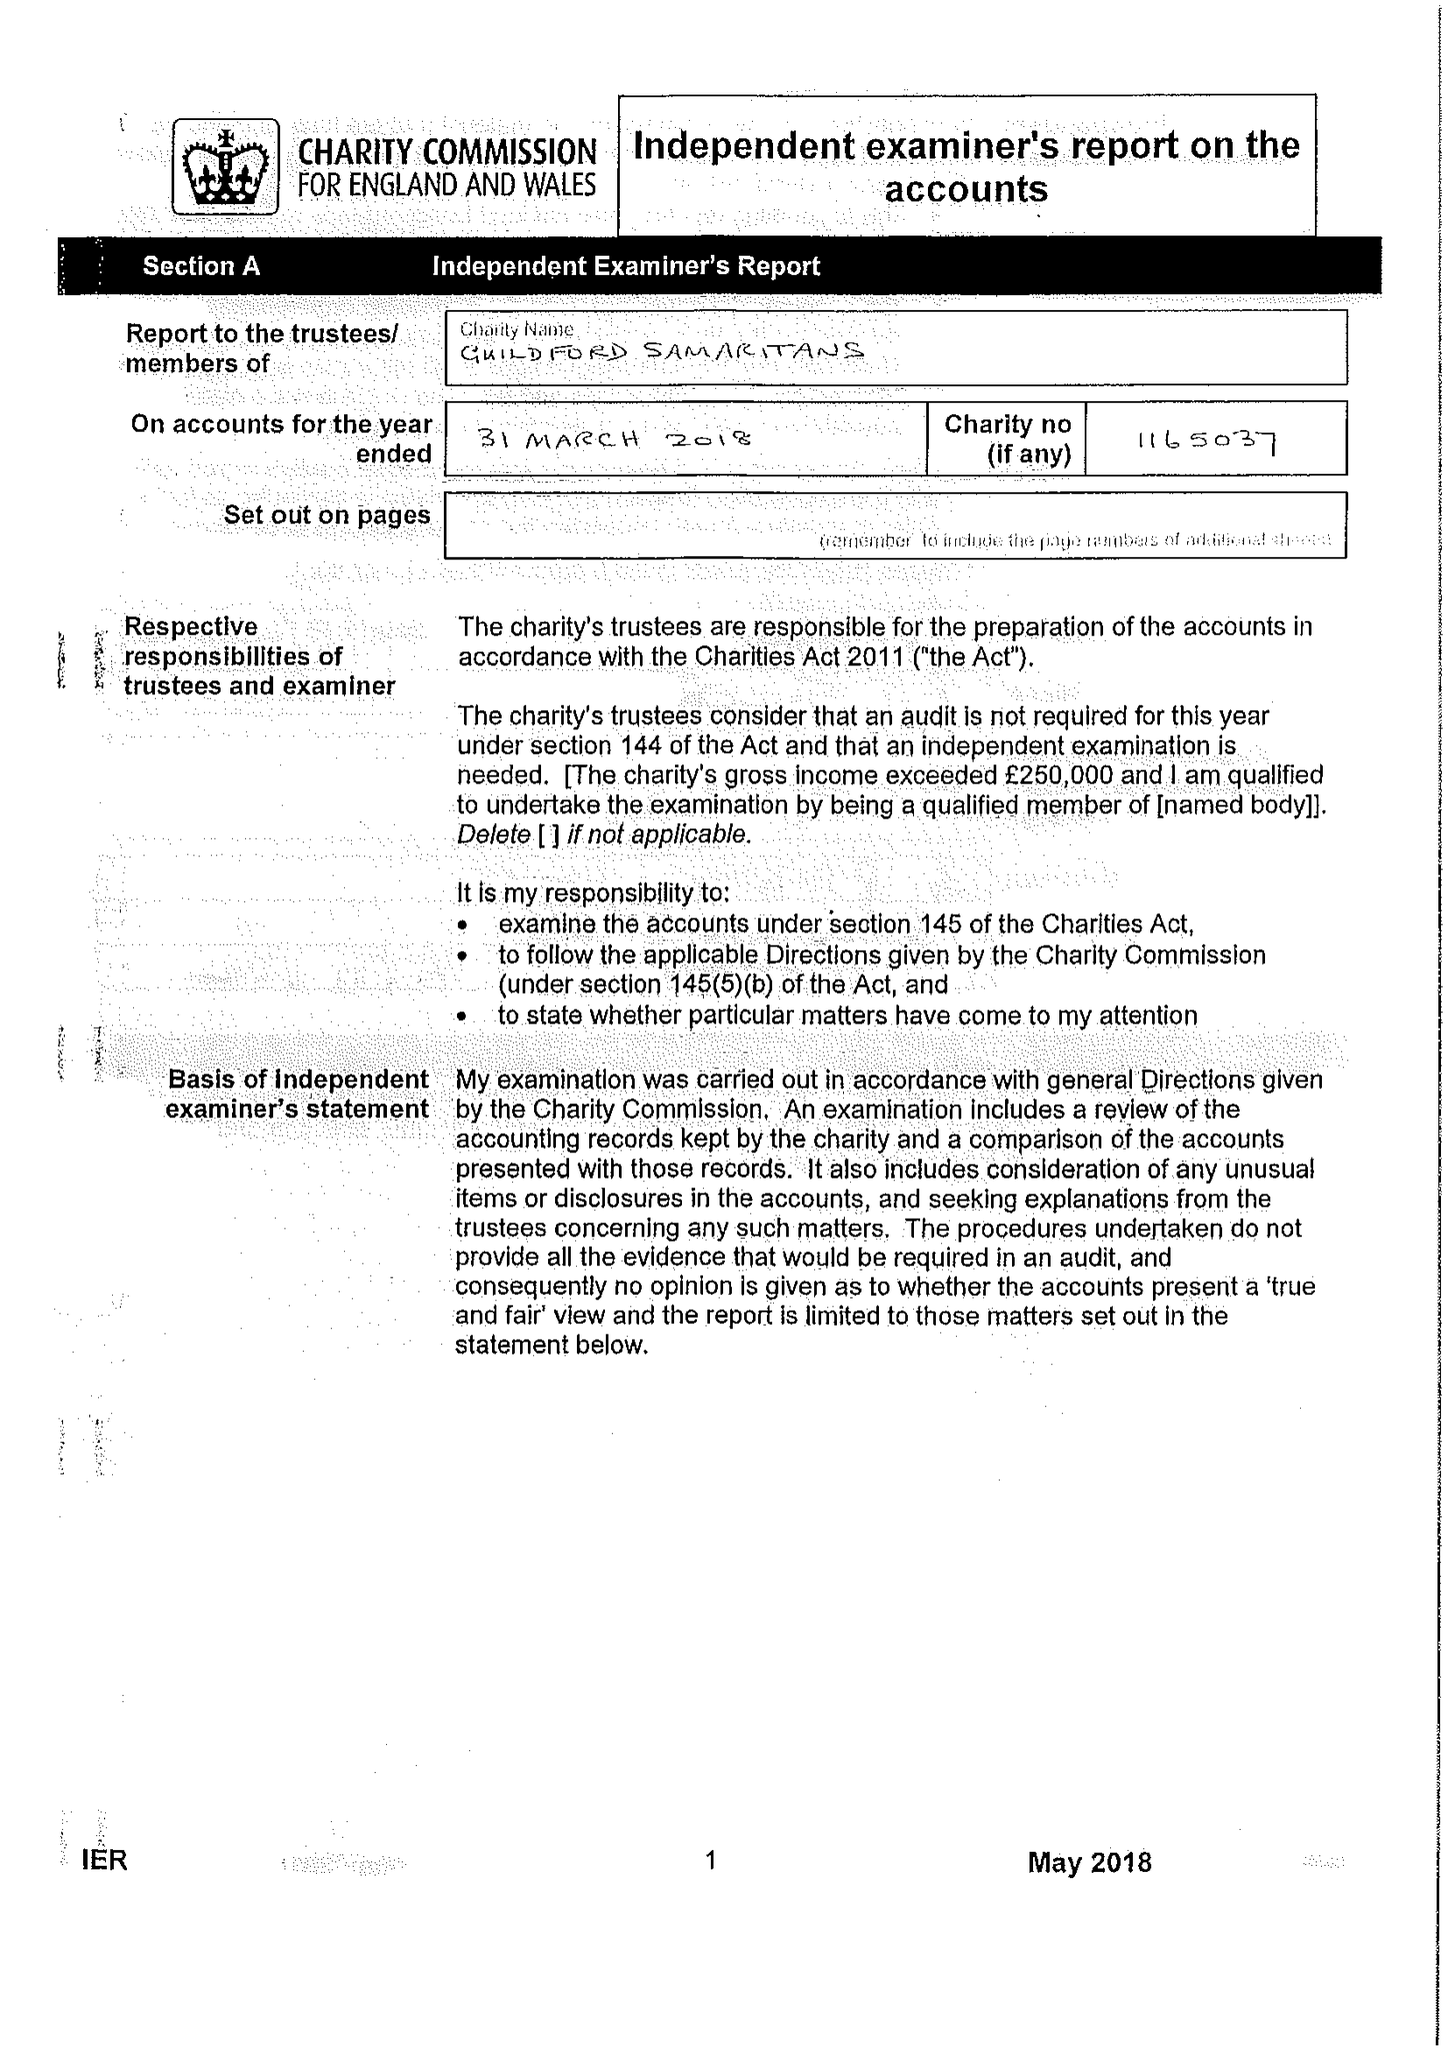What is the value for the spending_annually_in_british_pounds?
Answer the question using a single word or phrase. 181155.00 